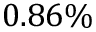<formula> <loc_0><loc_0><loc_500><loc_500>0 . 8 6 \%</formula> 